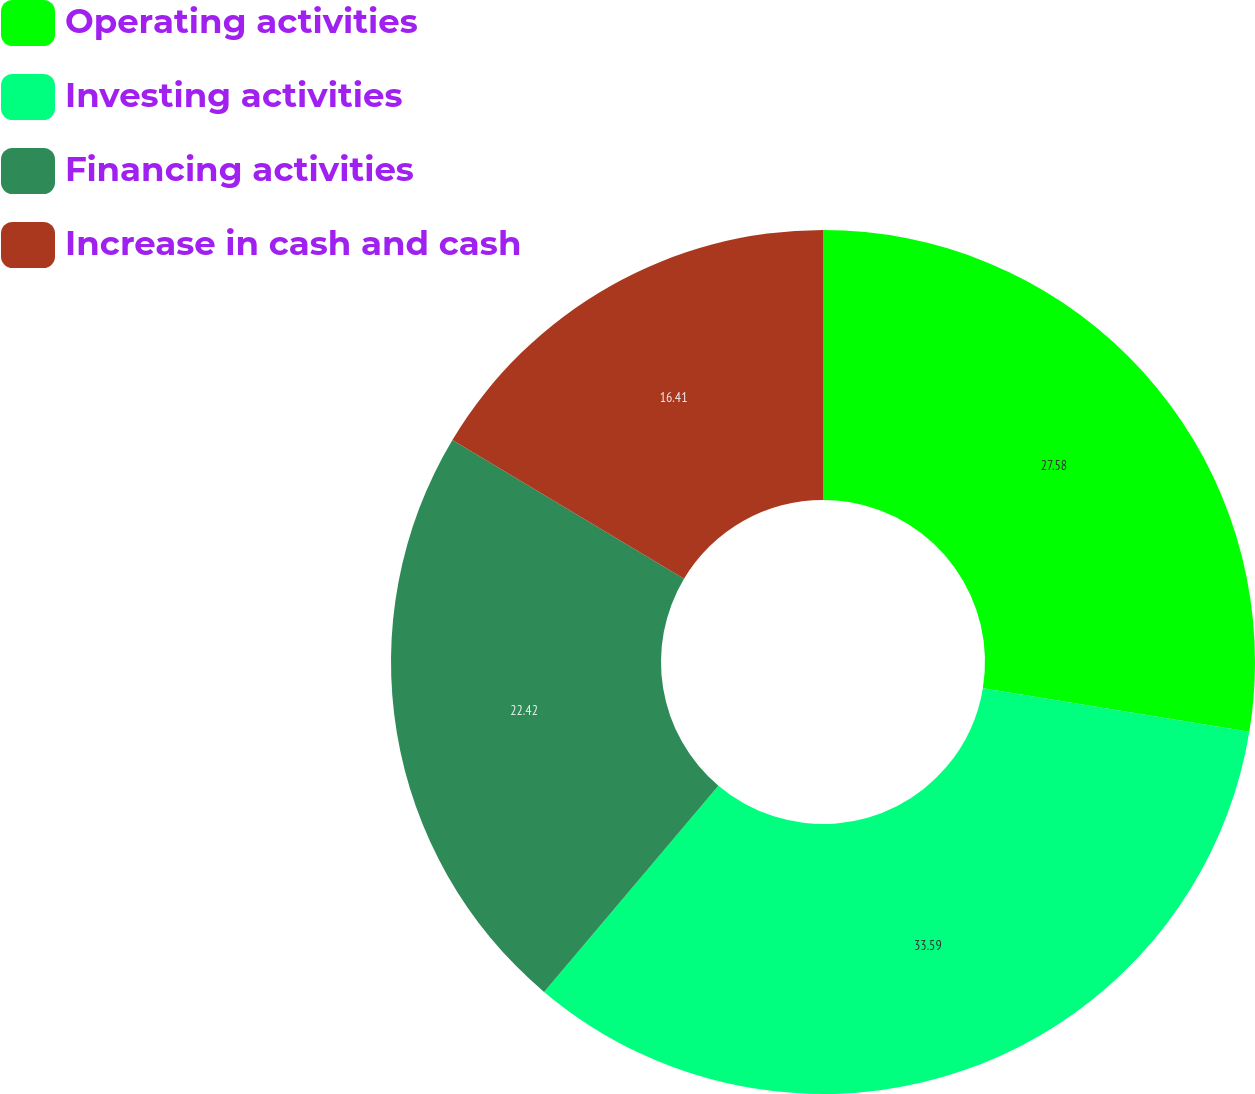Convert chart to OTSL. <chart><loc_0><loc_0><loc_500><loc_500><pie_chart><fcel>Operating activities<fcel>Investing activities<fcel>Financing activities<fcel>Increase in cash and cash<nl><fcel>27.58%<fcel>33.59%<fcel>22.42%<fcel>16.41%<nl></chart> 